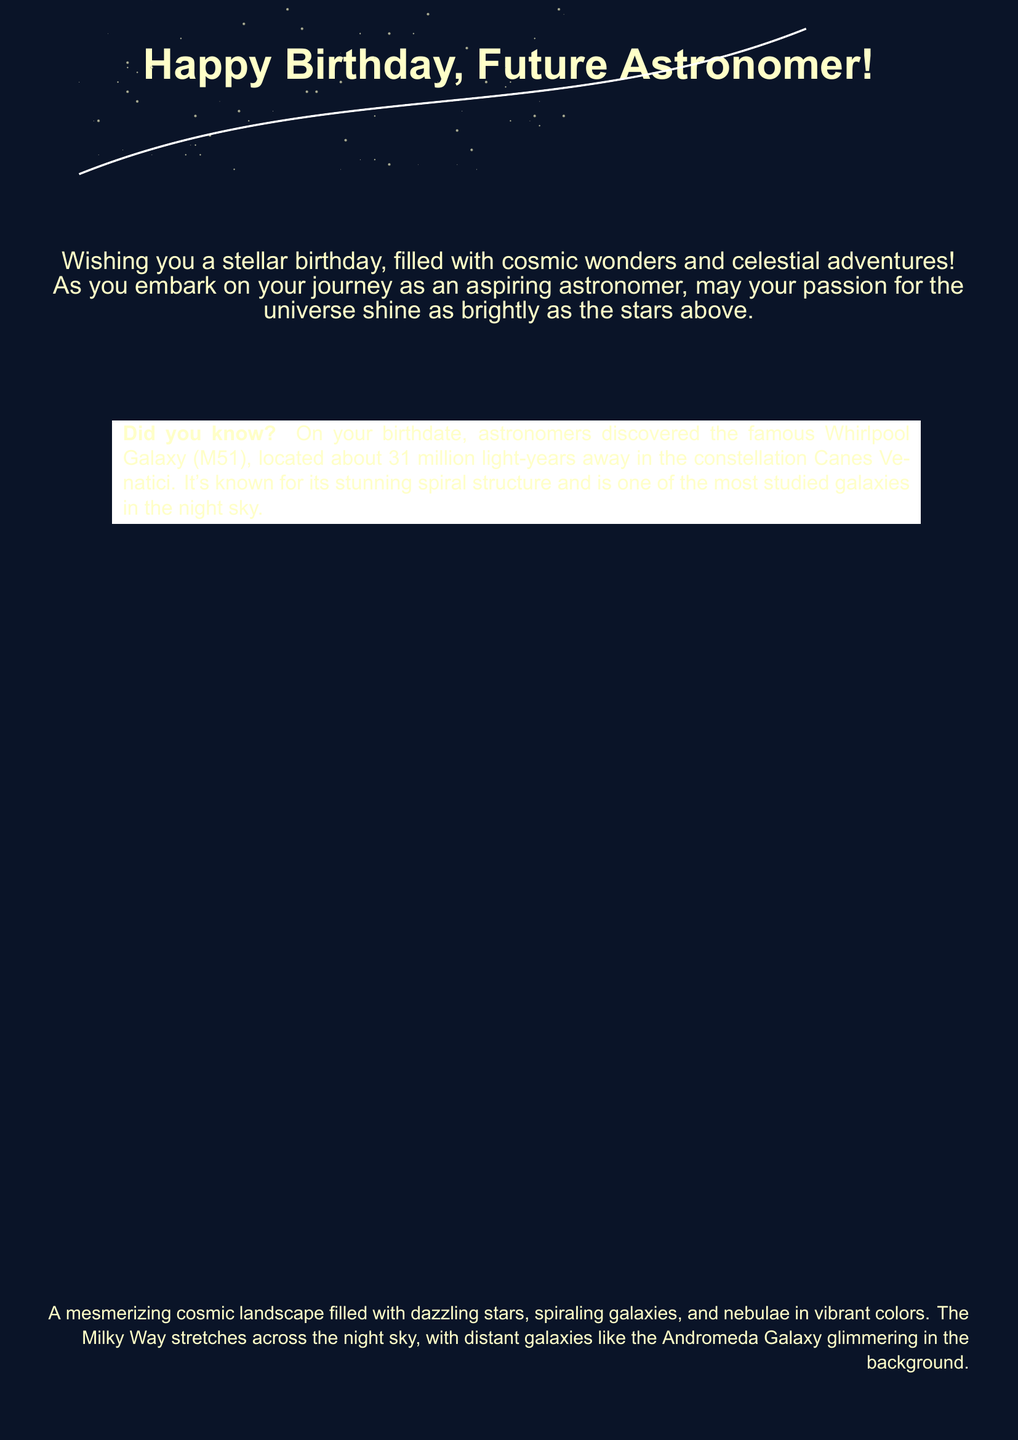What is the main message of the card? The main message of the card is wishing a happy birthday to a future astronomer and encouraging their passion for astronomy.
Answer: Happy Birthday, Future Astronomer! What galaxy was discovered on the birthdate mentioned? The greeting card includes a fun fact about a specific galaxy discovered on the birthdate.
Answer: Whirlpool Galaxy How far is the Whirlpool Galaxy from Earth? The document notes the distance of the Whirlpool Galaxy from Earth.
Answer: 31 million light-years In which constellation is the Whirlpool Galaxy located? The card specifies the constellation where the Whirlpool Galaxy can be found.
Answer: Canes Venatici What type of structure is the Whirlpool Galaxy known for? The card describes a characteristic feature of the Whirlpool Galaxy.
Answer: Spiral structure What color is the background of the card? The card's background color is specified in the document settings.
Answer: Nightsky What type of card is this document? The document clearly represents a specific type of celebratory note.
Answer: Greeting card What do the stars in the card represent? The stars serve a symbolic purpose in the card, related to the passion and journey of the recipient.
Answer: Cosmic wonders What kind of landscape is painted visually in the card? The description in the card conveys a specific type of scene in space.
Answer: Cosmic landscape 